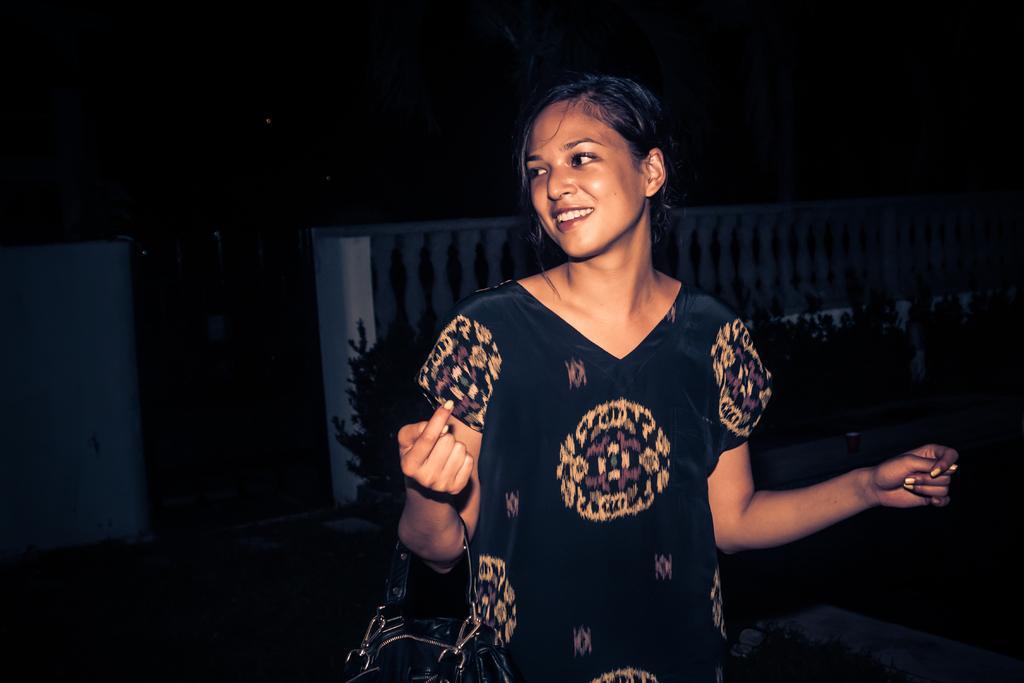In one or two sentences, can you explain what this image depicts? In this image we can see a lady holding a bag, behind her we can see few plants and a fence. 